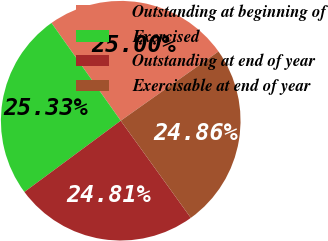Convert chart. <chart><loc_0><loc_0><loc_500><loc_500><pie_chart><fcel>Outstanding at beginning of<fcel>Exercised<fcel>Outstanding at end of year<fcel>Exercisable at end of year<nl><fcel>25.0%<fcel>25.33%<fcel>24.81%<fcel>24.86%<nl></chart> 